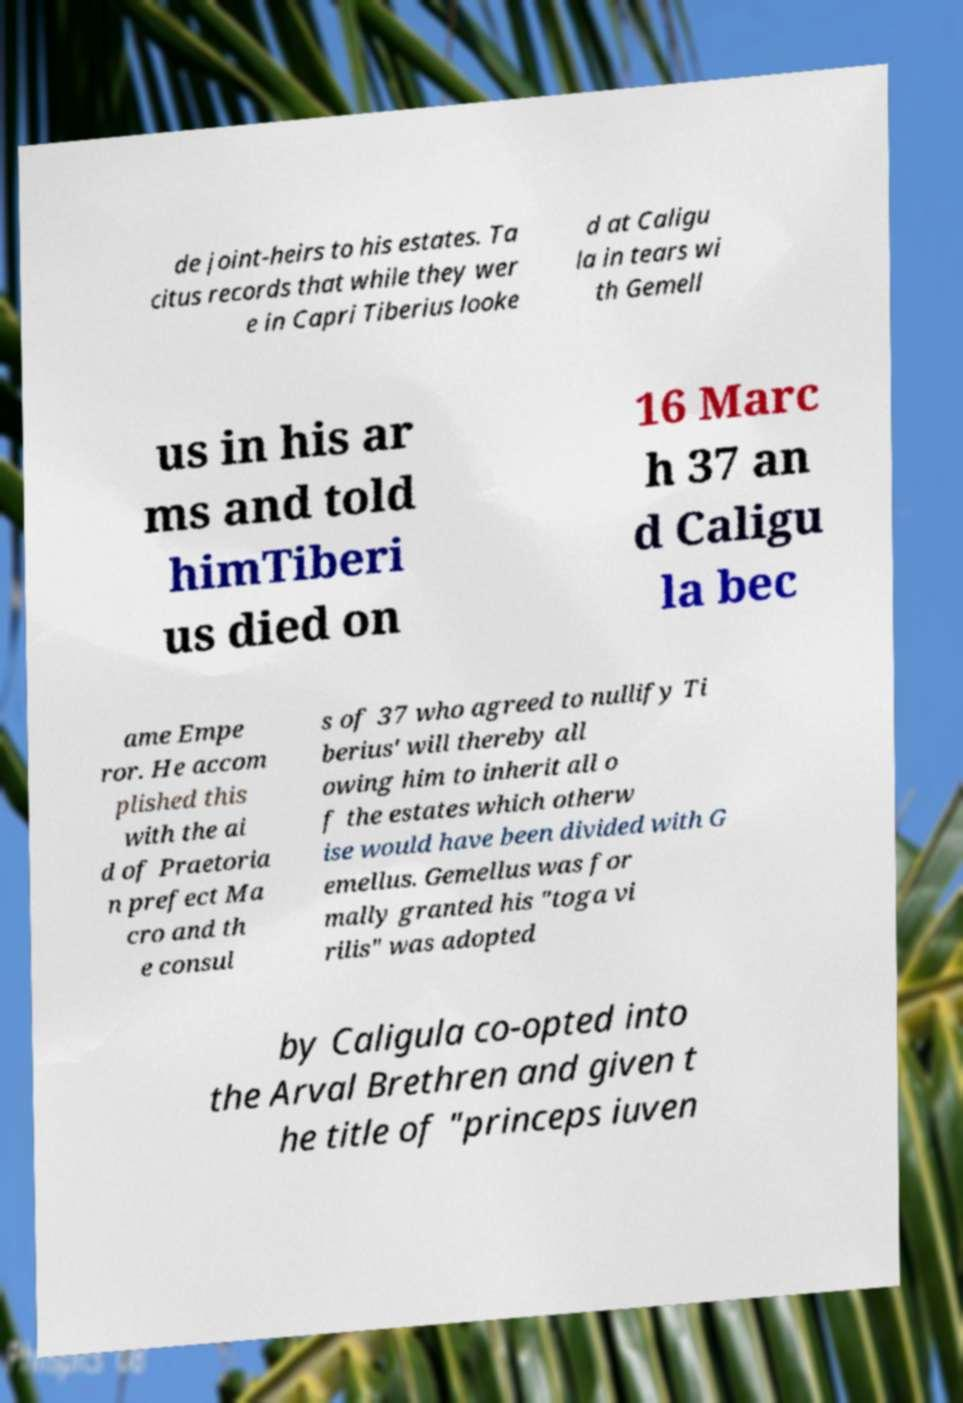Could you extract and type out the text from this image? de joint-heirs to his estates. Ta citus records that while they wer e in Capri Tiberius looke d at Caligu la in tears wi th Gemell us in his ar ms and told himTiberi us died on 16 Marc h 37 an d Caligu la bec ame Empe ror. He accom plished this with the ai d of Praetoria n prefect Ma cro and th e consul s of 37 who agreed to nullify Ti berius' will thereby all owing him to inherit all o f the estates which otherw ise would have been divided with G emellus. Gemellus was for mally granted his "toga vi rilis" was adopted by Caligula co-opted into the Arval Brethren and given t he title of "princeps iuven 